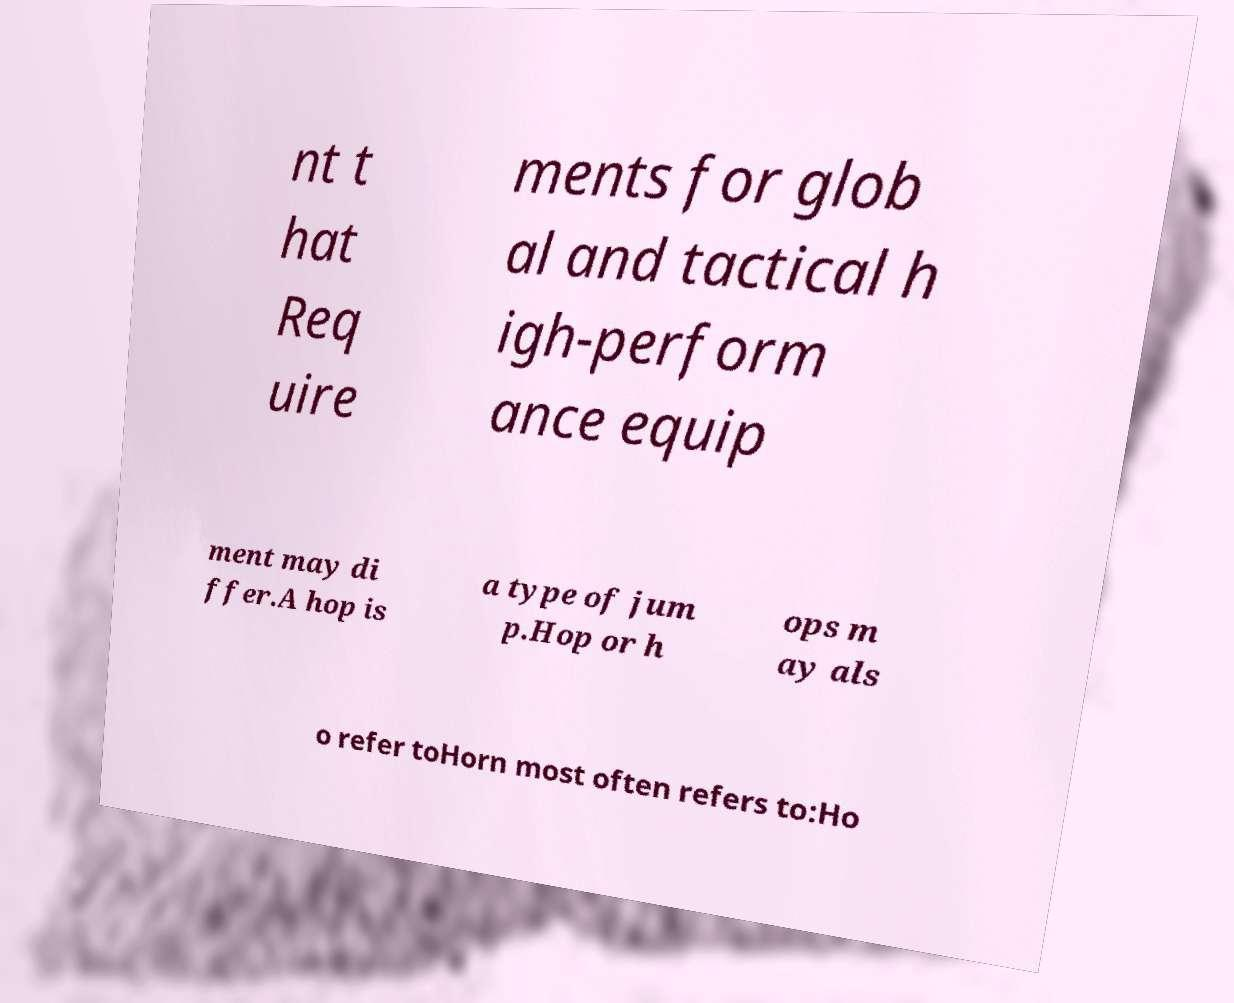What messages or text are displayed in this image? I need them in a readable, typed format. nt t hat Req uire ments for glob al and tactical h igh-perform ance equip ment may di ffer.A hop is a type of jum p.Hop or h ops m ay als o refer toHorn most often refers to:Ho 